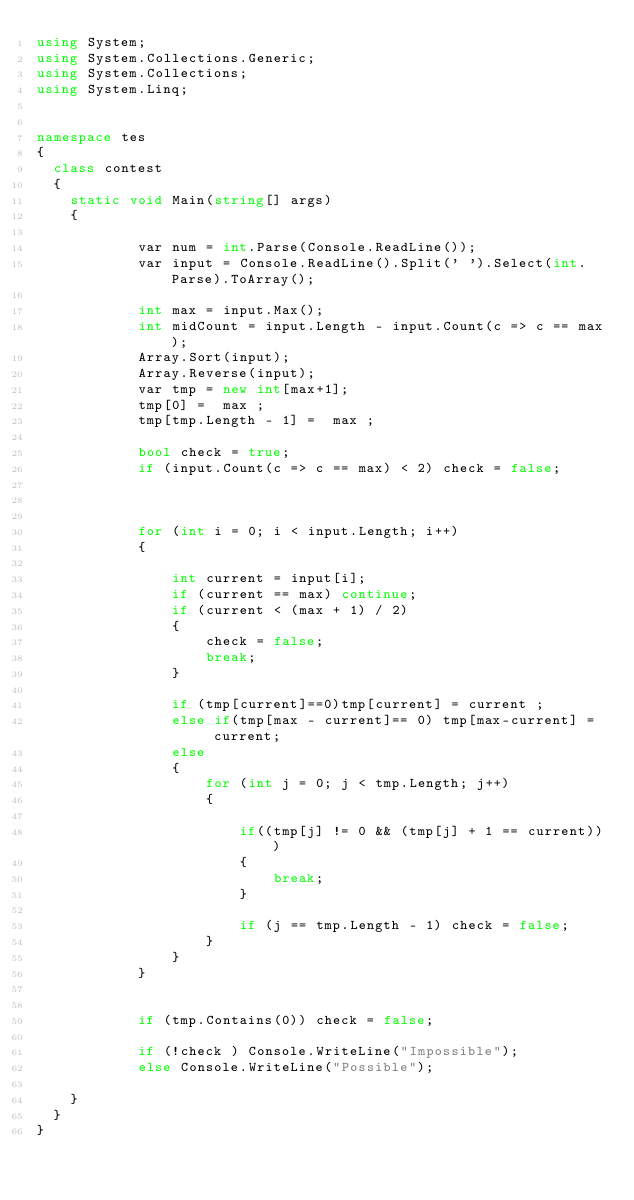Convert code to text. <code><loc_0><loc_0><loc_500><loc_500><_C#_>using System;
using System.Collections.Generic;
using System.Collections;
using System.Linq;


namespace tes
{
	class contest
	{
		static void Main(string[] args)
		{
			 
            var num = int.Parse(Console.ReadLine());
            var input = Console.ReadLine().Split(' ').Select(int.Parse).ToArray();

            int max = input.Max();
            int midCount = input.Length - input.Count(c => c == max);
            Array.Sort(input);
            Array.Reverse(input);
            var tmp = new int[max+1];
            tmp[0] =  max ;
            tmp[tmp.Length - 1] =  max ;

            bool check = true;
            if (input.Count(c => c == max) < 2) check = false; 
            
           
            
            for (int i = 0; i < input.Length; i++)
            {
               
                int current = input[i];
                if (current == max) continue;
                if (current < (max + 1) / 2)
                {
                    check = false;
                    break;
                }

                if (tmp[current]==0)tmp[current] = current ;
                else if(tmp[max - current]== 0) tmp[max-current] =  current;
                else
                {
                    for (int j = 0; j < tmp.Length; j++)
                    {
                        
                        if((tmp[j] != 0 && (tmp[j] + 1 == current)))
                        {
                            break;
                        }

                        if (j == tmp.Length - 1) check = false;
                    }
                }
            }


            if (tmp.Contains(0)) check = false;

            if (!check ) Console.WriteLine("Impossible");
            else Console.WriteLine("Possible");

		}				 
	}
}</code> 